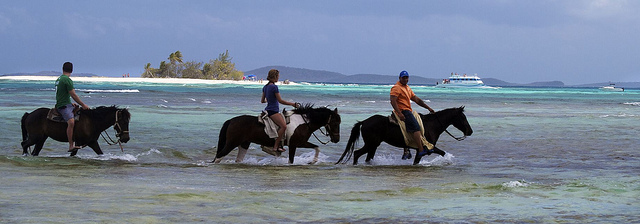How many horses are visible? 3 